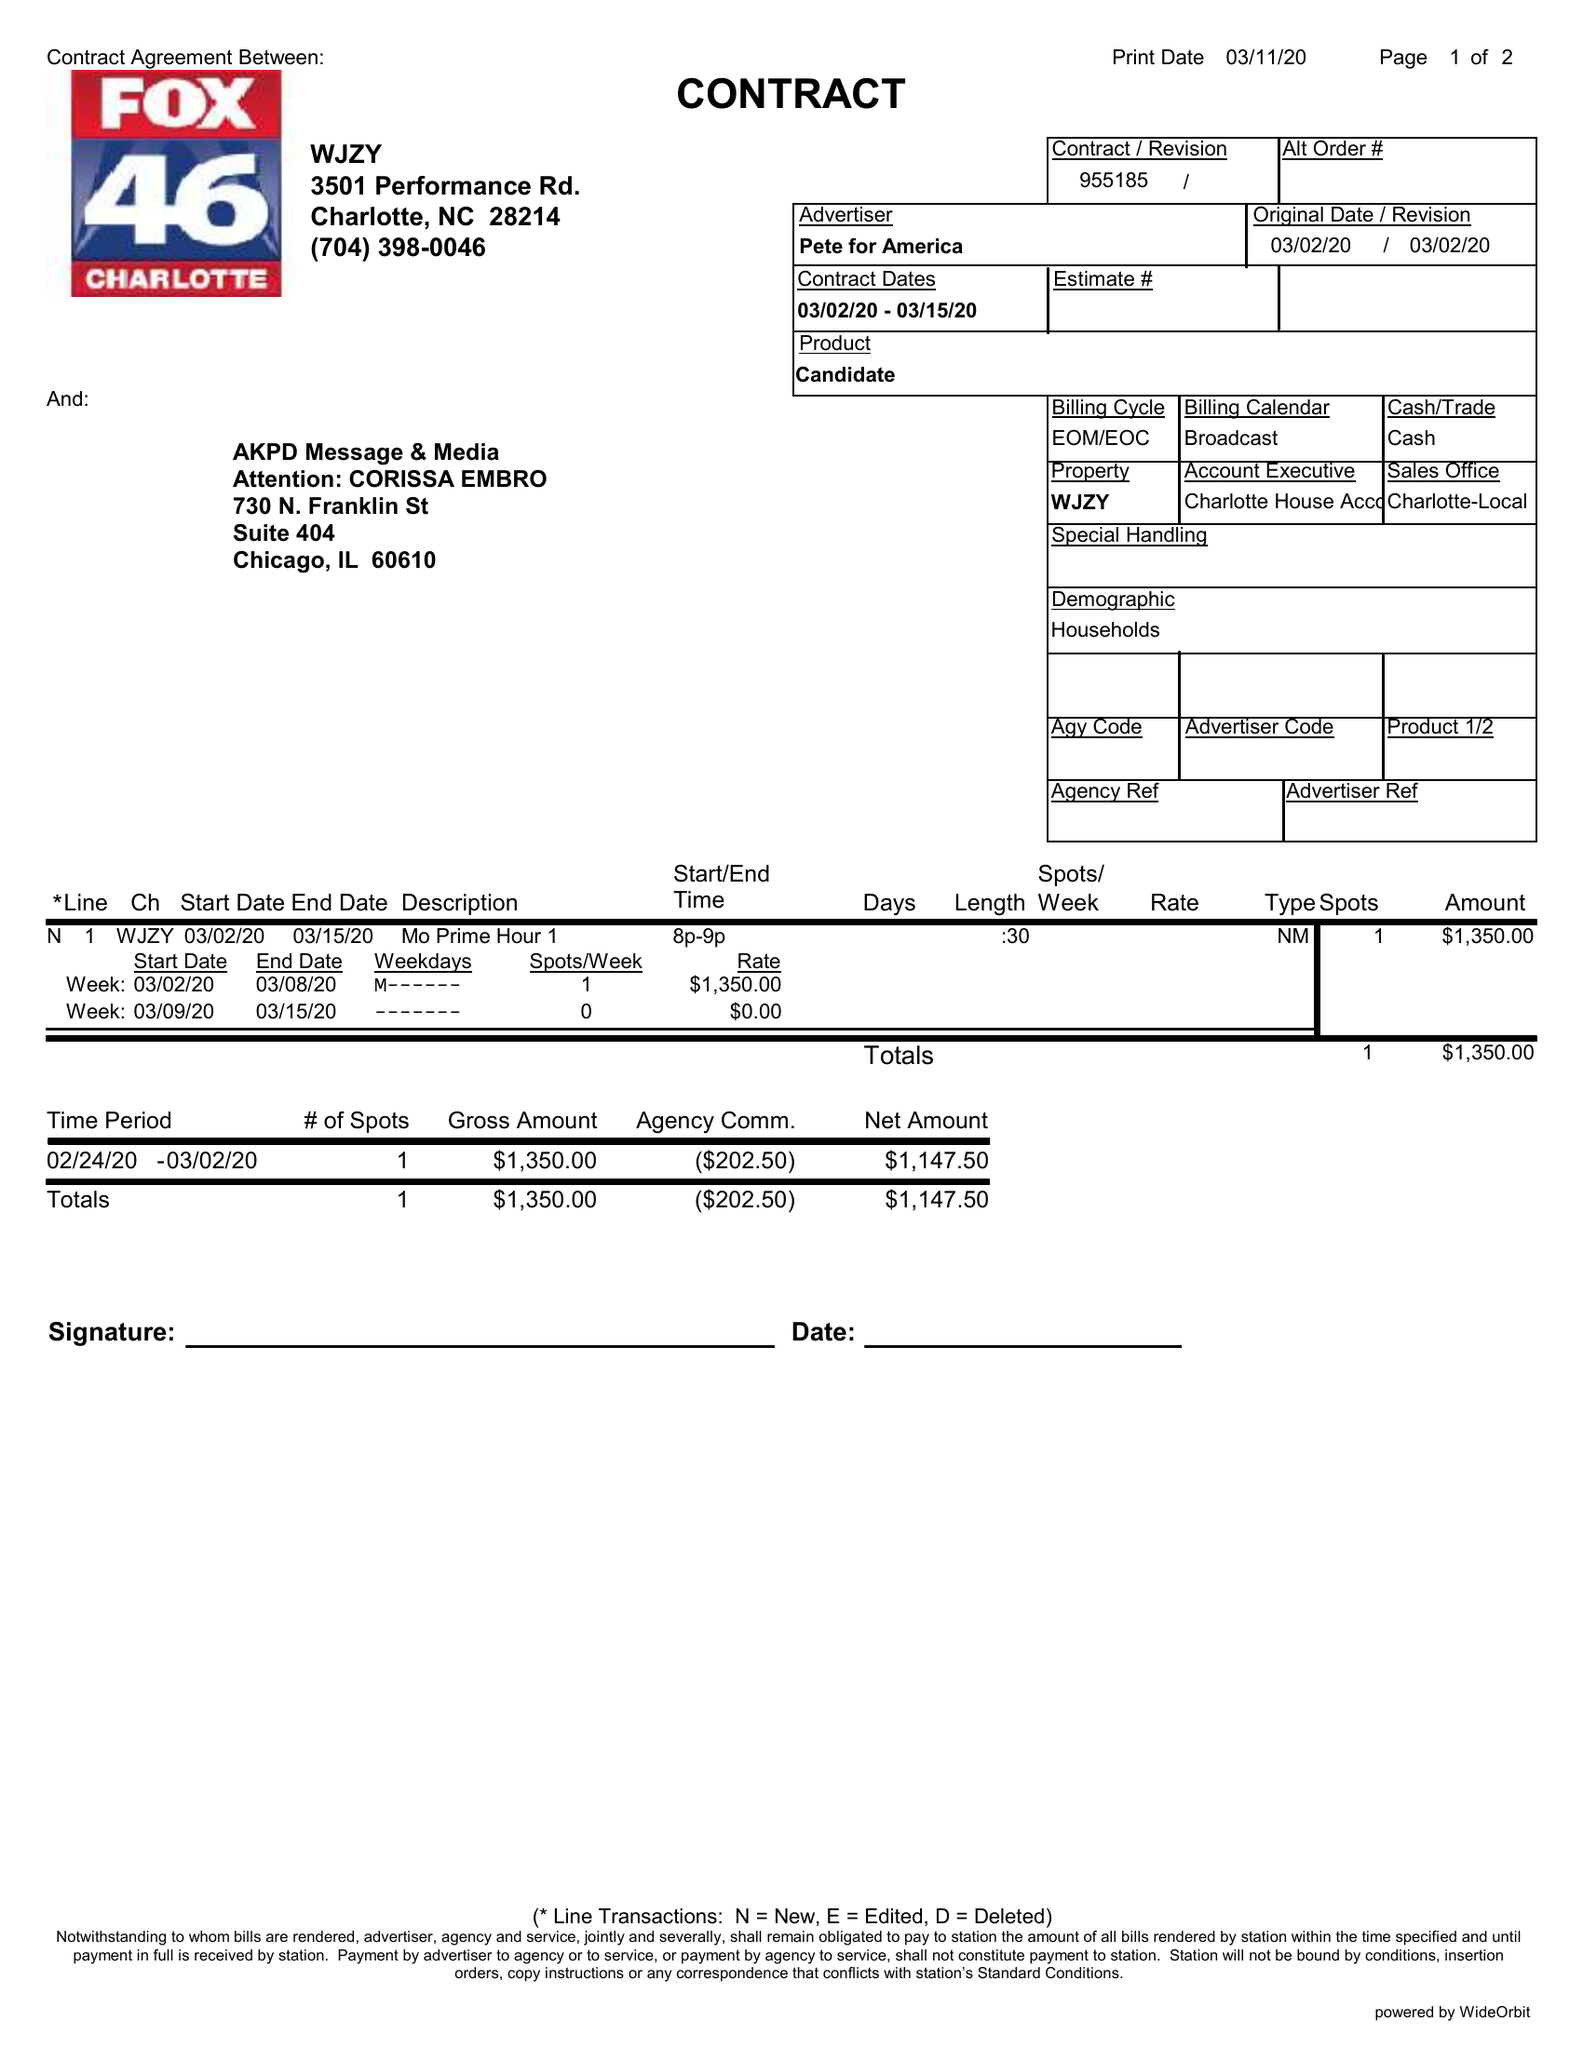What is the value for the contract_num?
Answer the question using a single word or phrase. 955185 